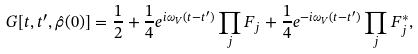<formula> <loc_0><loc_0><loc_500><loc_500>G [ t , t ^ { \prime } , \hat { \rho } ( 0 ) ] = \frac { 1 } { 2 } + \frac { 1 } { 4 } e ^ { i \omega _ { V } ( t - t ^ { \prime } ) } \prod _ { j } F _ { j } + \frac { 1 } { 4 } e ^ { - i \omega _ { V } ( t - t ^ { \prime } ) } \prod _ { j } F _ { j } ^ { * } ,</formula> 